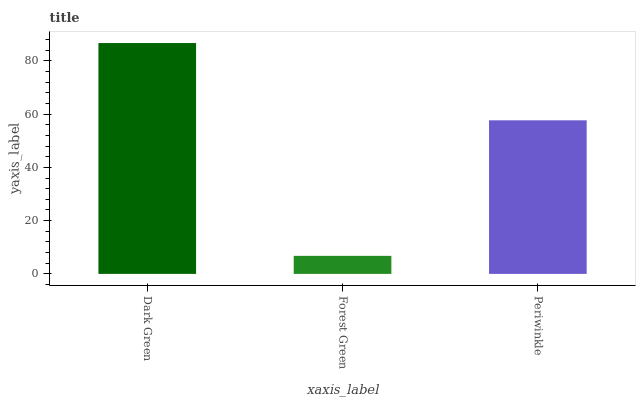Is Forest Green the minimum?
Answer yes or no. Yes. Is Dark Green the maximum?
Answer yes or no. Yes. Is Periwinkle the minimum?
Answer yes or no. No. Is Periwinkle the maximum?
Answer yes or no. No. Is Periwinkle greater than Forest Green?
Answer yes or no. Yes. Is Forest Green less than Periwinkle?
Answer yes or no. Yes. Is Forest Green greater than Periwinkle?
Answer yes or no. No. Is Periwinkle less than Forest Green?
Answer yes or no. No. Is Periwinkle the high median?
Answer yes or no. Yes. Is Periwinkle the low median?
Answer yes or no. Yes. Is Dark Green the high median?
Answer yes or no. No. Is Dark Green the low median?
Answer yes or no. No. 